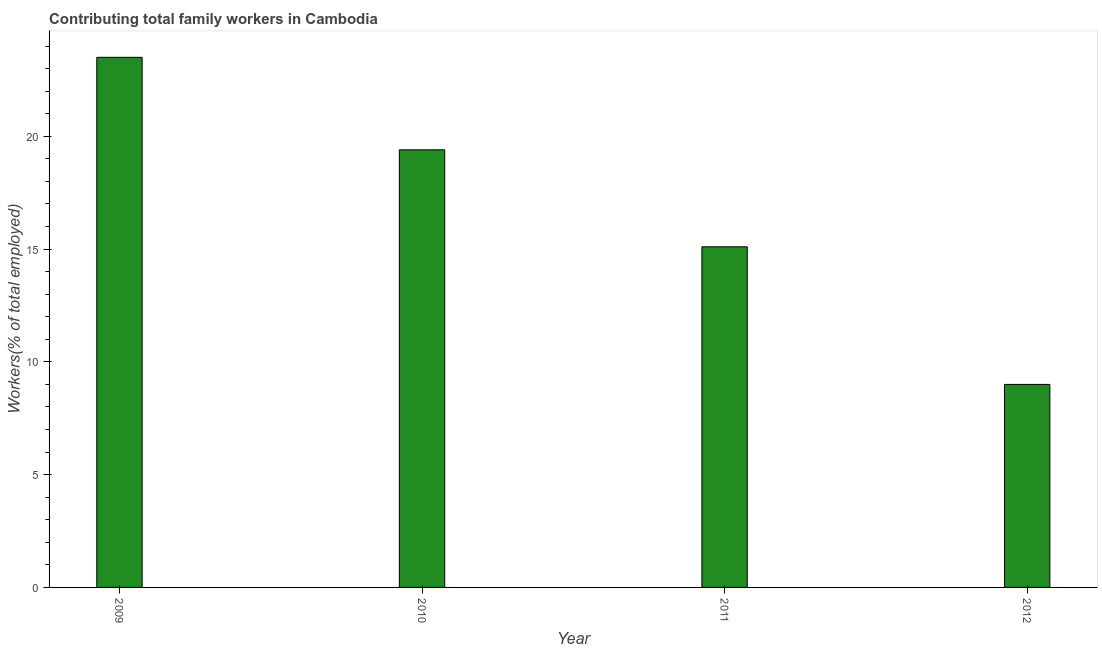Does the graph contain any zero values?
Your response must be concise. No. Does the graph contain grids?
Your response must be concise. No. What is the title of the graph?
Provide a succinct answer. Contributing total family workers in Cambodia. What is the label or title of the Y-axis?
Provide a succinct answer. Workers(% of total employed). What is the contributing family workers in 2010?
Provide a short and direct response. 19.4. Across all years, what is the minimum contributing family workers?
Keep it short and to the point. 9. In which year was the contributing family workers maximum?
Your answer should be very brief. 2009. What is the sum of the contributing family workers?
Offer a terse response. 67. What is the average contributing family workers per year?
Provide a short and direct response. 16.75. What is the median contributing family workers?
Ensure brevity in your answer.  17.25. What is the ratio of the contributing family workers in 2009 to that in 2011?
Provide a succinct answer. 1.56. Is the contributing family workers in 2011 less than that in 2012?
Your answer should be compact. No. Is the difference between the contributing family workers in 2010 and 2012 greater than the difference between any two years?
Make the answer very short. No. What is the difference between the highest and the second highest contributing family workers?
Ensure brevity in your answer.  4.1. Is the sum of the contributing family workers in 2009 and 2011 greater than the maximum contributing family workers across all years?
Your response must be concise. Yes. What is the difference between the highest and the lowest contributing family workers?
Make the answer very short. 14.5. How many bars are there?
Your answer should be very brief. 4. Are all the bars in the graph horizontal?
Make the answer very short. No. What is the difference between two consecutive major ticks on the Y-axis?
Your response must be concise. 5. Are the values on the major ticks of Y-axis written in scientific E-notation?
Offer a very short reply. No. What is the Workers(% of total employed) of 2010?
Ensure brevity in your answer.  19.4. What is the Workers(% of total employed) in 2011?
Your answer should be very brief. 15.1. What is the Workers(% of total employed) in 2012?
Your answer should be compact. 9. What is the difference between the Workers(% of total employed) in 2009 and 2010?
Your answer should be very brief. 4.1. What is the difference between the Workers(% of total employed) in 2009 and 2012?
Your answer should be very brief. 14.5. What is the difference between the Workers(% of total employed) in 2010 and 2011?
Offer a terse response. 4.3. What is the difference between the Workers(% of total employed) in 2010 and 2012?
Keep it short and to the point. 10.4. What is the ratio of the Workers(% of total employed) in 2009 to that in 2010?
Provide a succinct answer. 1.21. What is the ratio of the Workers(% of total employed) in 2009 to that in 2011?
Provide a short and direct response. 1.56. What is the ratio of the Workers(% of total employed) in 2009 to that in 2012?
Your response must be concise. 2.61. What is the ratio of the Workers(% of total employed) in 2010 to that in 2011?
Offer a very short reply. 1.28. What is the ratio of the Workers(% of total employed) in 2010 to that in 2012?
Make the answer very short. 2.16. What is the ratio of the Workers(% of total employed) in 2011 to that in 2012?
Your answer should be compact. 1.68. 